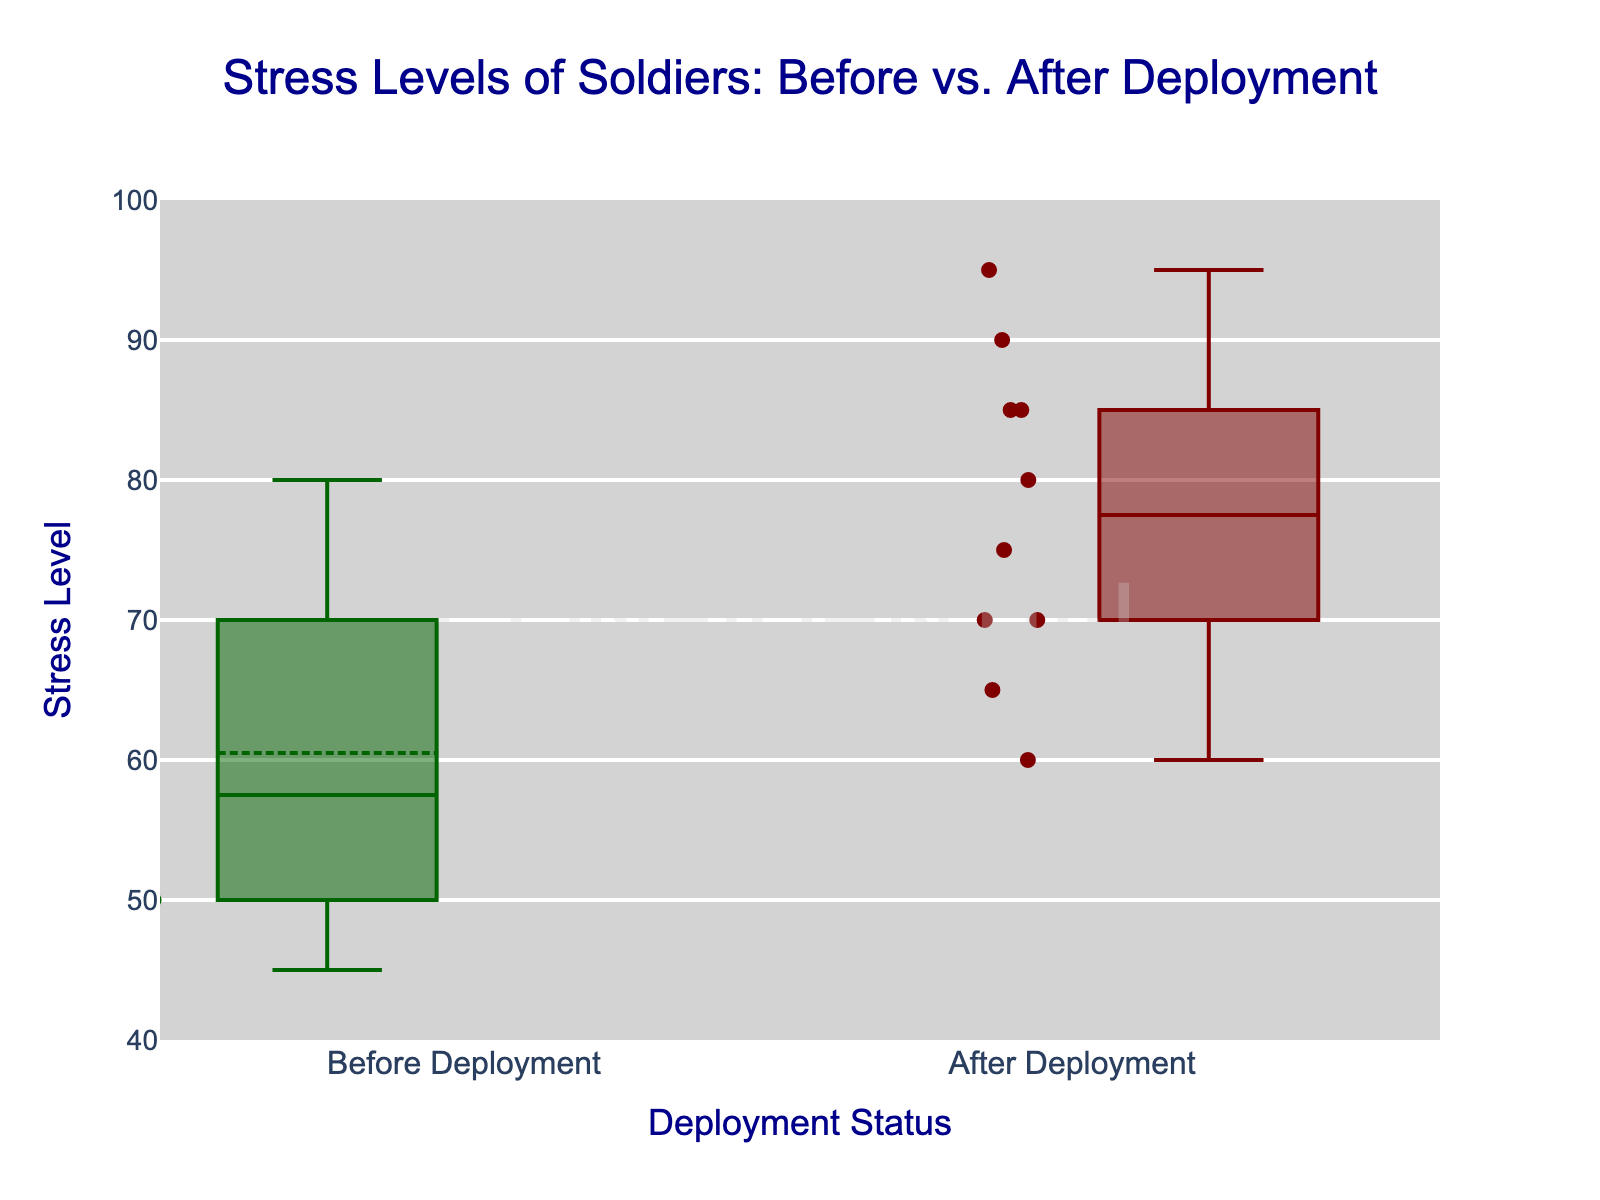What's the title of the plot? The title is located at the top center of the plot and is clearly indicated in a specific font and color.
Answer: Stress Levels of Soldiers: Before vs. After Deployment What is the range of the y-axis? The y-axis range is located along the left side of the plot, with values and step intervals indicating the minimum and maximum values.
Answer: 40 to 100 How many individual data points are there in the 'After Deployment' group? The plot displays all individual data points for each group, allowing us to count them easily.
Answer: 10 Which group has the higher median stress level? To find this, look at the line inside the box that represents the median in each group's box plot. Compare the positions of these lines.
Answer: After Deployment What is the color used for the 'Before Deployment' group? The color of the box plots is indicated by a specific shade assigned to each group; 'Before Deployment' is displayed in one distinct color.
Answer: Dark green What is the median stress level for the 'Before Deployment' group? The median is shown by the line inside the box of the 'Before Deployment' group. Find this median line and read the corresponding y-axis value.
Answer: 60 What is the difference in the median stress level between the 'Before Deployment' and 'After Deployment' groups? First, determine the median stress levels of both groups from their respective box plots. Then, calculate the difference between these two values.
Answer: 20 Which group has the wider interquartile range (IQR)? The IQR is represented by the height of the box in each box plot. Measure the length of each box to determine which is wider.
Answer: After Deployment What's the maximum stress level observed in the 'After Deployment' group? The maximum stress level can be identified by looking at the top whisker or outliers in the 'After Deployment' box plot.
Answer: 95 Are there any outliers in the 'Before Deployment' group? Outliers are shown as individual points outside the whiskers of the box plot. Look for any points falling outside the top or bottom whiskers in the 'Before Deployment' group.
Answer: No 